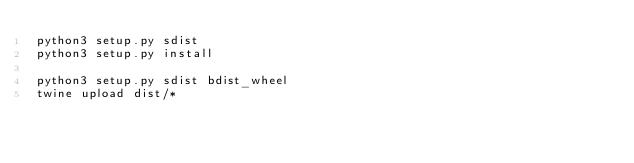<code> <loc_0><loc_0><loc_500><loc_500><_Bash_>python3 setup.py sdist
python3 setup.py install

python3 setup.py sdist bdist_wheel
twine upload dist/*   </code> 